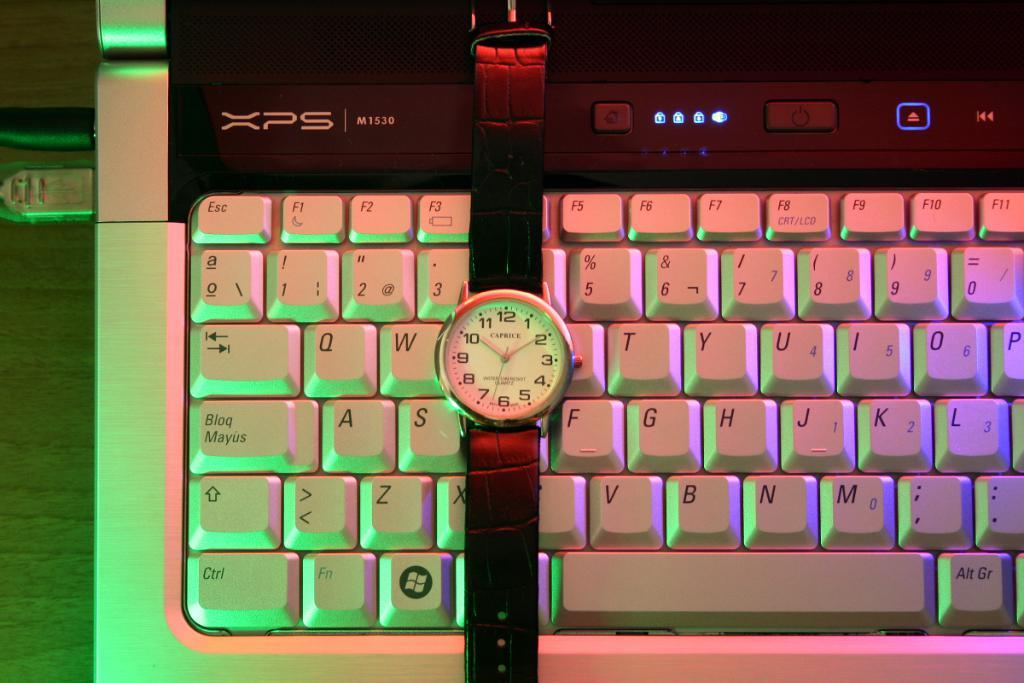<image>
Provide a brief description of the given image. A Caprice watch sits on top of a computer keyboard. 